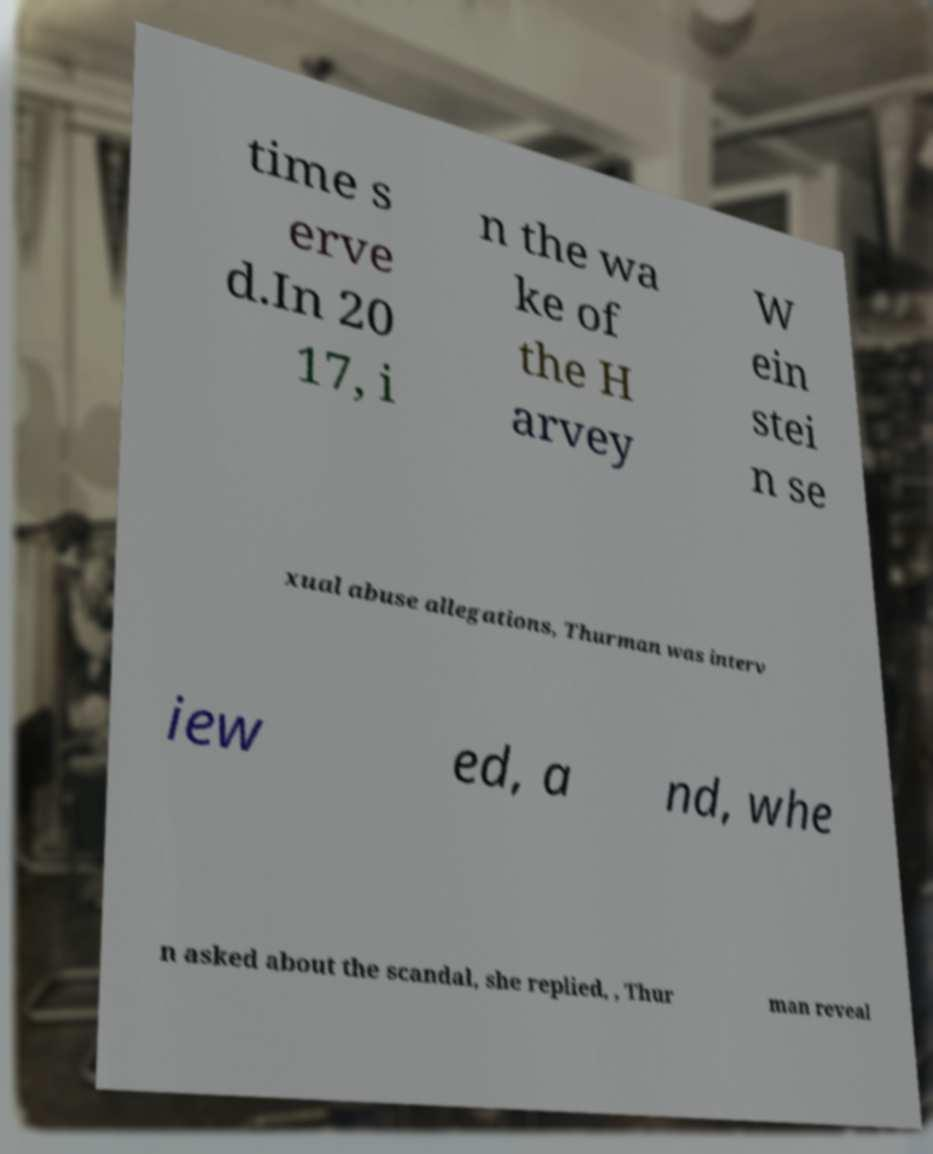For documentation purposes, I need the text within this image transcribed. Could you provide that? time s erve d.In 20 17, i n the wa ke of the H arvey W ein stei n se xual abuse allegations, Thurman was interv iew ed, a nd, whe n asked about the scandal, she replied, , Thur man reveal 